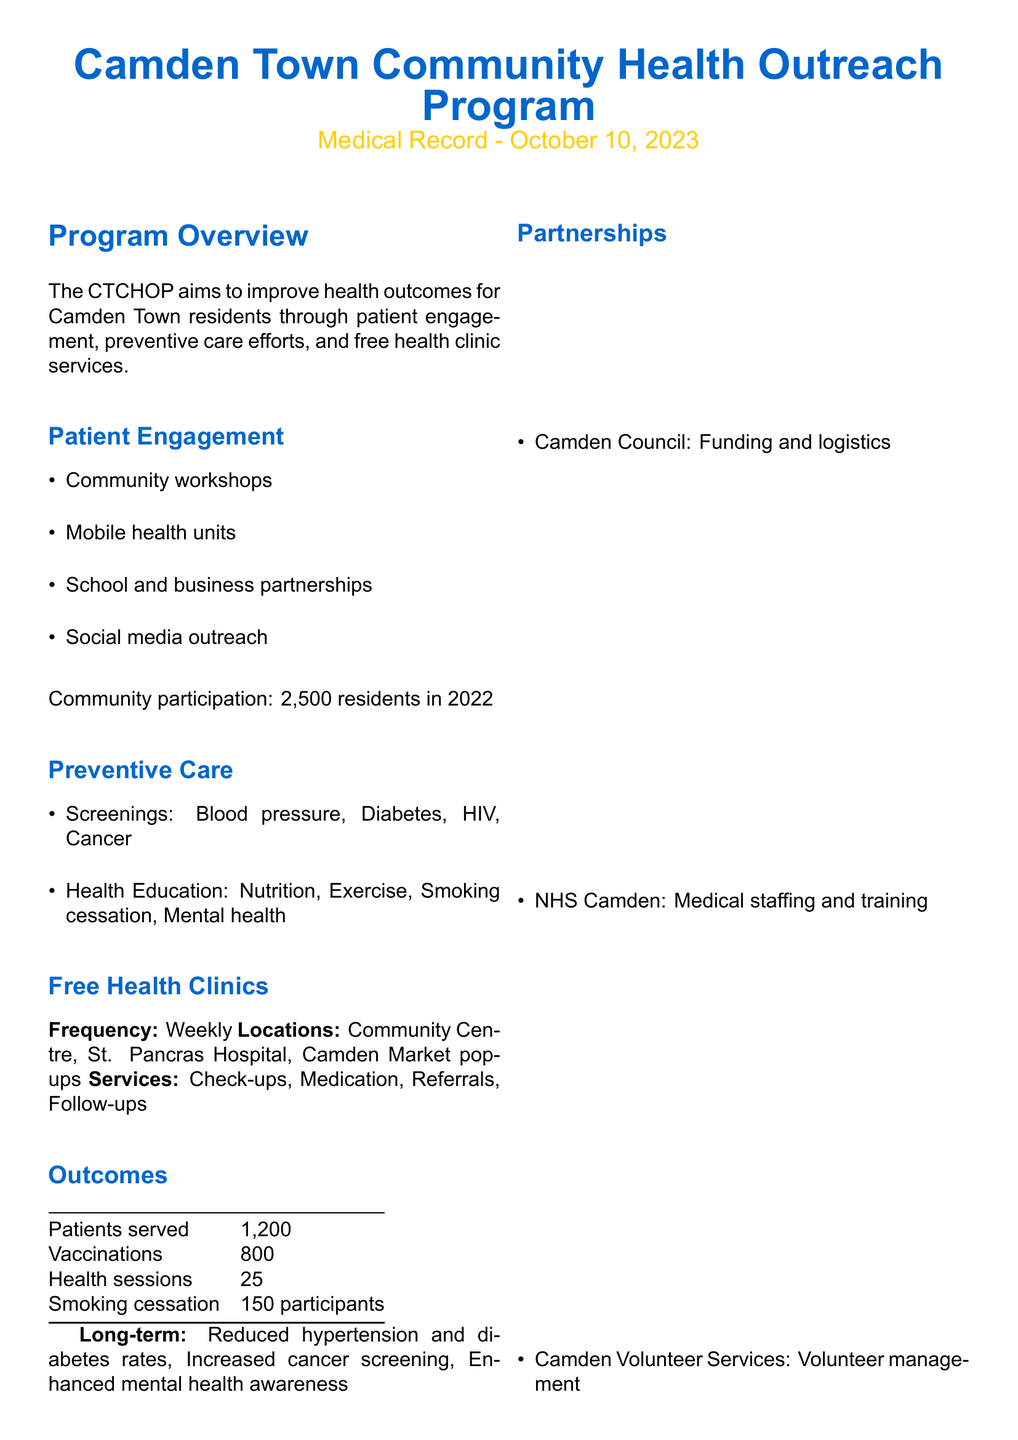What is the name of the program? The name of the program is mentioned in the title of the document, which is the Camden Town Community Health Outreach Program.
Answer: Camden Town Community Health Outreach Program When was the medical record created? The date is specified in the subtitle of the document.
Answer: October 10, 2023 How many patients were served by the program? The number of patients served is stated in the outcomes section of the document.
Answer: 1,200 What is the frequency of the free health clinics? The frequency of the clinics is mentioned in the free health clinics section.
Answer: Weekly How many vaccinations were provided? The total number of vaccinations is listed in the outcomes section.
Answer: 800 Who provided funding and logistics for the program? The funding and logistics provider is specified under the partnerships section.
Answer: Camden Council What type of health education topics were covered? The health education topics are listed in the preventive care section.
Answer: Nutrition, Exercise, Smoking cessation, Mental health What was one long-term outcome of the program? One of the long-term outcomes is indicated in the outcomes section.
Answer: Reduced hypertension and diabetes rates What kind of program was mentioned by a participant named David Brown? This is derived from the testimonials section of the document.
Answer: Smoking cessation program 